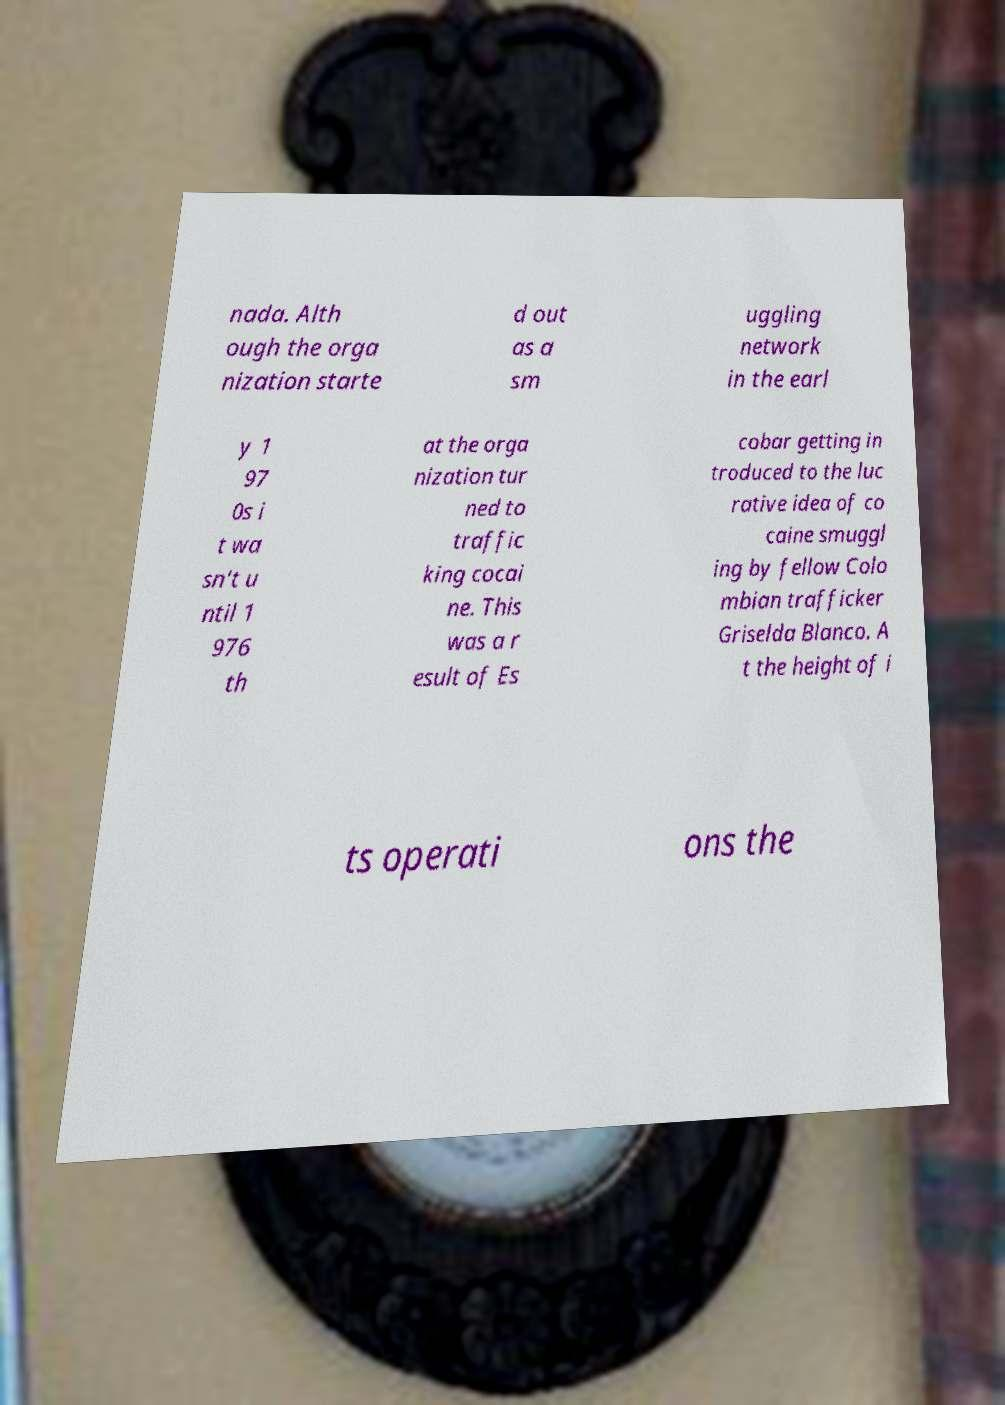Can you read and provide the text displayed in the image?This photo seems to have some interesting text. Can you extract and type it out for me? nada. Alth ough the orga nization starte d out as a sm uggling network in the earl y 1 97 0s i t wa sn't u ntil 1 976 th at the orga nization tur ned to traffic king cocai ne. This was a r esult of Es cobar getting in troduced to the luc rative idea of co caine smuggl ing by fellow Colo mbian trafficker Griselda Blanco. A t the height of i ts operati ons the 